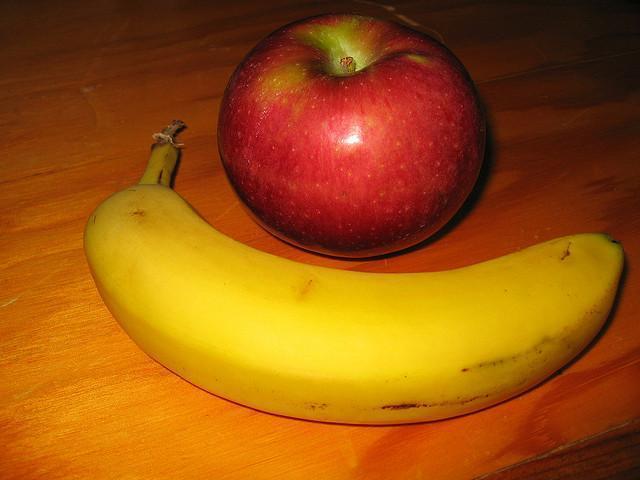Verify the accuracy of this image caption: "The apple is behind the banana.".
Answer yes or no. Yes. Does the image validate the caption "The banana is over the apple."?
Answer yes or no. No. 